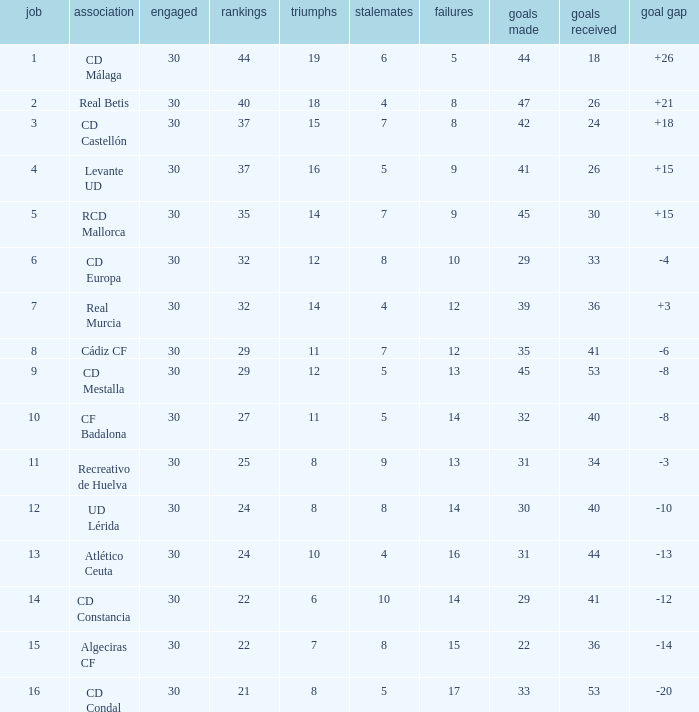What is the number of draws when played is smaller than 30? 0.0. 